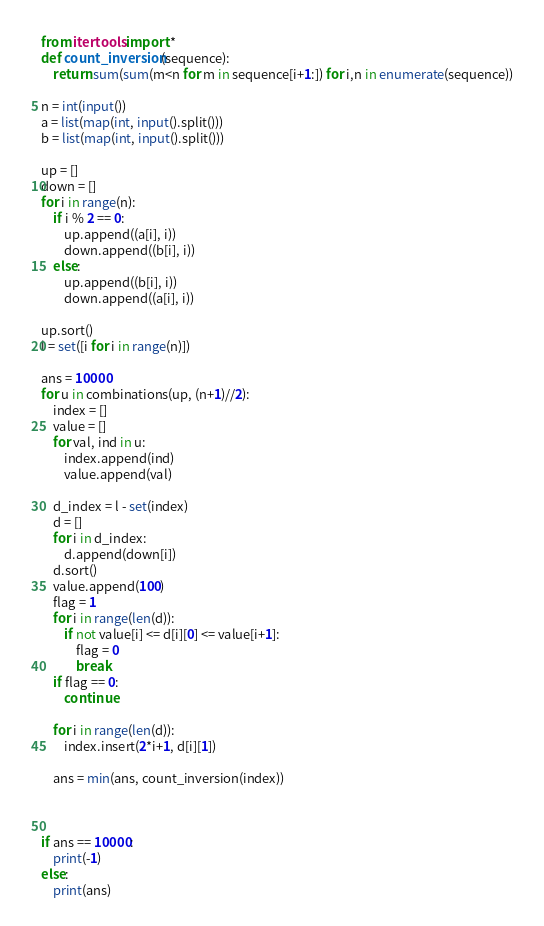Convert code to text. <code><loc_0><loc_0><loc_500><loc_500><_Python_>from itertools import *
def count_inversion(sequence):
    return sum(sum(m<n for m in sequence[i+1:]) for i,n in enumerate(sequence))

n = int(input())
a = list(map(int, input().split()))
b = list(map(int, input().split()))

up = []
down = []
for i in range(n):
    if i % 2 == 0:
        up.append((a[i], i))
        down.append((b[i], i))
    else:
        up.append((b[i], i))
        down.append((a[i], i))

up.sort()
l = set([i for i in range(n)])

ans = 10000
for u in combinations(up, (n+1)//2):
    index = []
    value = []
    for val, ind in u:
        index.append(ind)
        value.append(val)

    d_index = l - set(index)
    d = []
    for i in d_index:
        d.append(down[i])
    d.sort()
    value.append(100)
    flag = 1
    for i in range(len(d)):
        if not value[i] <= d[i][0] <= value[i+1]:
            flag = 0
            break
    if flag == 0:
        continue

    for i in range(len(d)):
        index.insert(2*i+1, d[i][1])

    ans = min(ans, count_inversion(index))



if ans == 10000:
    print(-1)
else:
    print(ans)
</code> 